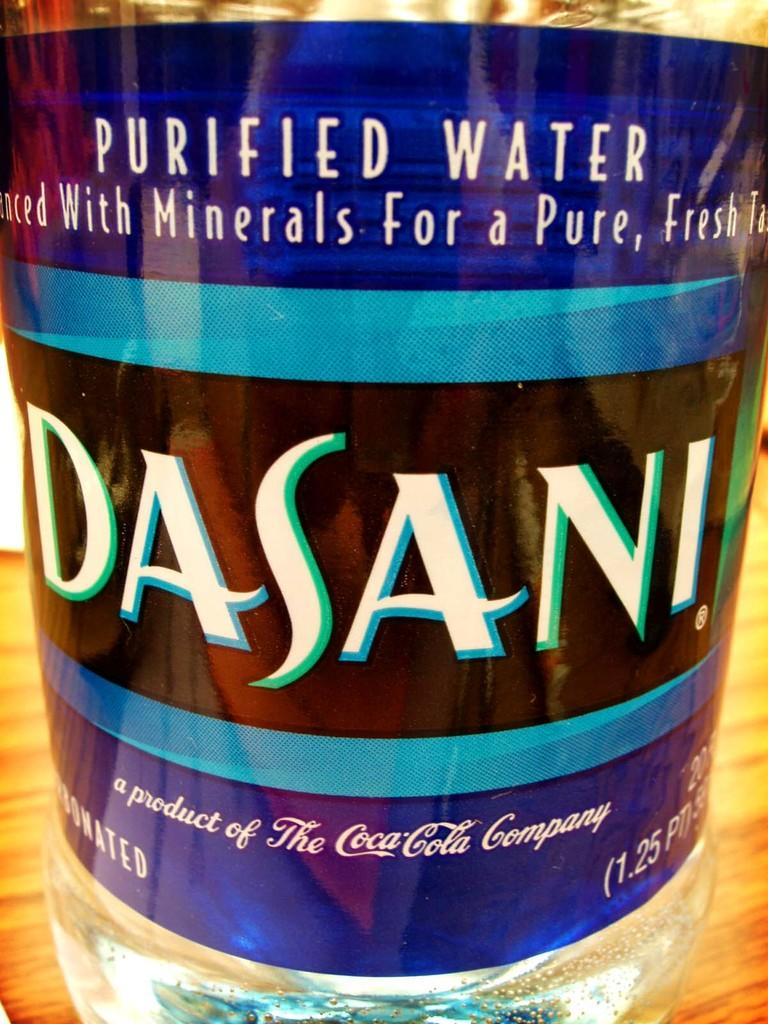What object can be seen in the image? There is a bottle in the image. Can you describe the damage caused by the earthquake in the image? There is no earthquake present in the image, and therefore no damage can be observed. What type of bee can be seen buzzing around the bottle in the image? There are no bees present in the image; it only features a bottle. 